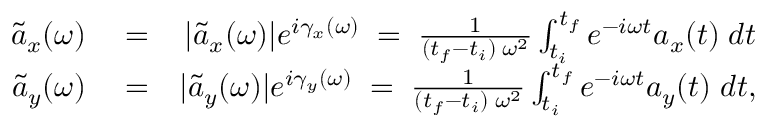Convert formula to latex. <formula><loc_0><loc_0><loc_500><loc_500>\begin{array} { r l r } { \tilde { a } _ { x } ( \omega ) } & = } & { | \tilde { a } _ { x } ( \omega ) | e ^ { i \gamma _ { x } ( \omega ) } \, = \, \frac { 1 } { ( t _ { f } - t _ { i } ) \, \omega ^ { 2 } } \int _ { t _ { i } } ^ { t _ { f } } e ^ { - i \omega t } a _ { x } ( t ) \, d t } \\ { \tilde { a } _ { y } ( \omega ) } & = } & { | \tilde { a } _ { y } ( \omega ) | e ^ { i \gamma _ { y } ( \omega ) } \, = \, \frac { 1 } { ( t _ { f } - t _ { i } ) \, \omega ^ { 2 } } \int _ { t _ { i } } ^ { t _ { f } } e ^ { - i \omega t } a _ { y } ( t ) \, d t , } \end{array}</formula> 